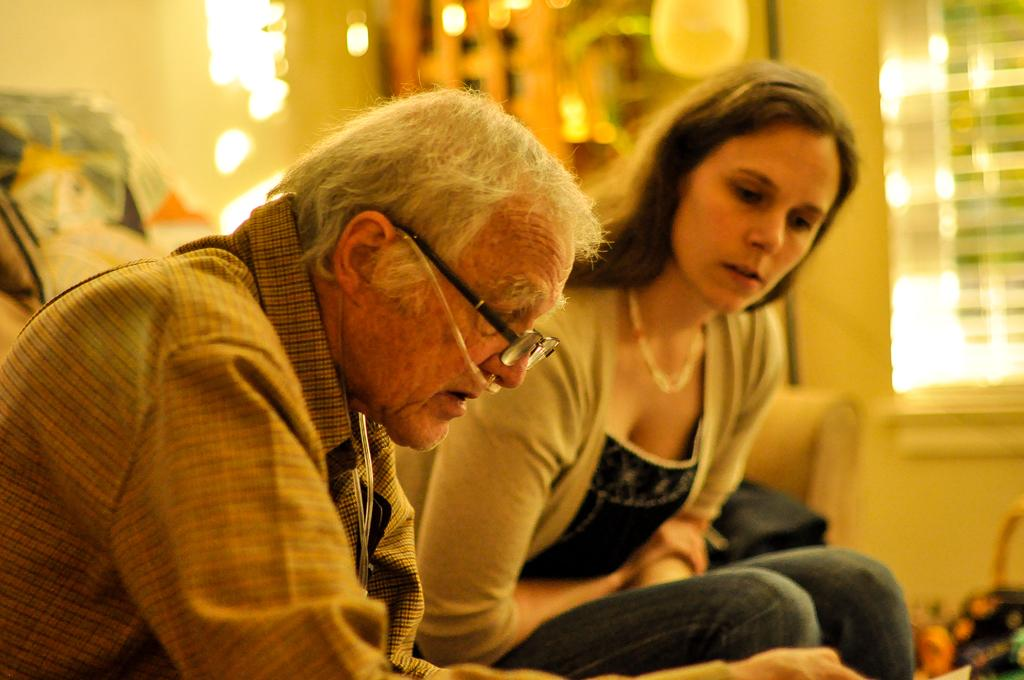How many people are in the image? There are two persons in the image. What are the persons doing in the image? The persons are sitting on a couch. What can be seen behind the persons in the image? There is a wall visible in the image. How would you describe the background of the image? The background of the image is blurred. What type of drug is being discussed by the persons in the image? There is no indication in the image that the persons are discussing any drugs, so it cannot be determined from the picture. 